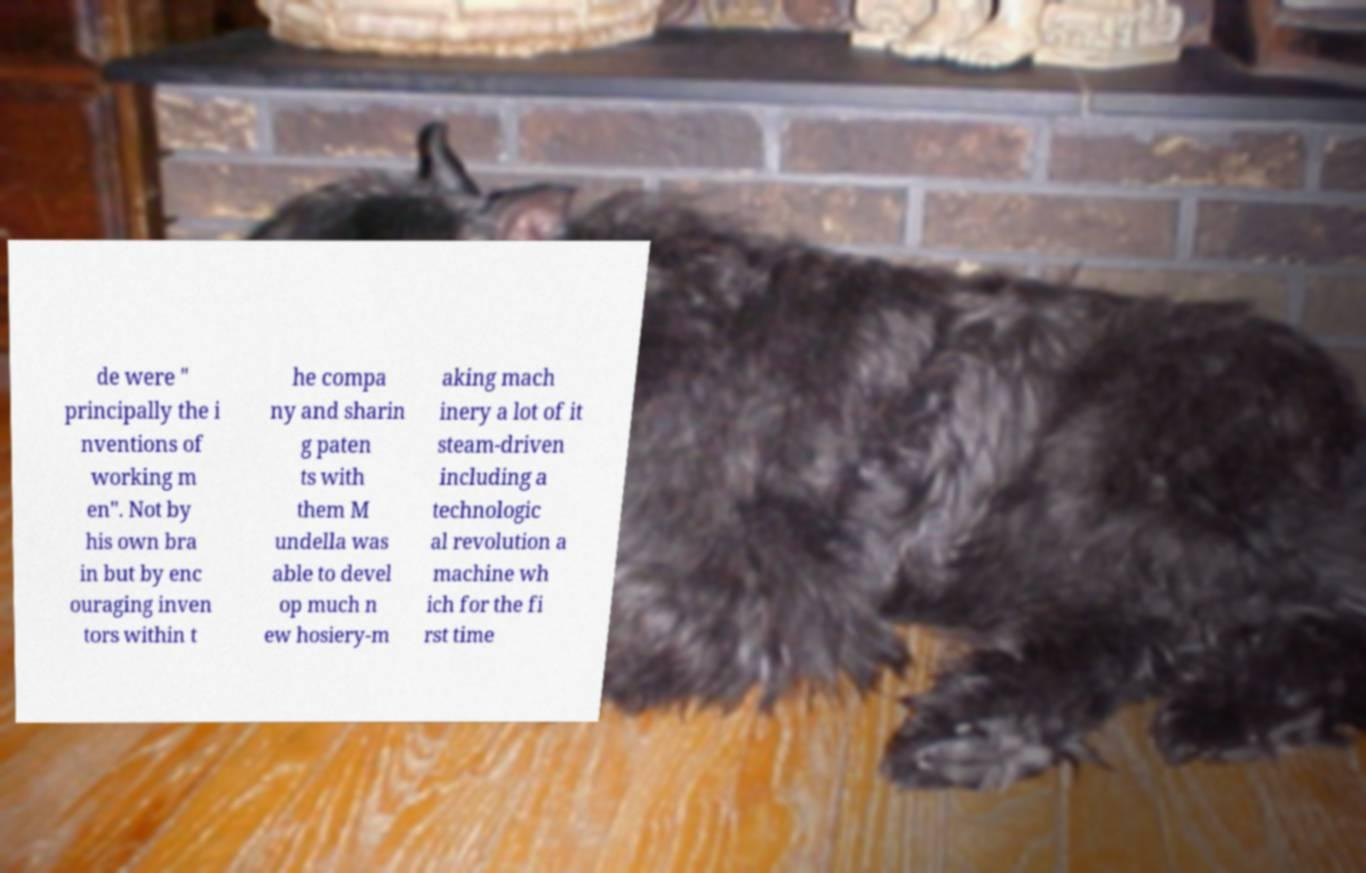I need the written content from this picture converted into text. Can you do that? de were " principally the i nventions of working m en". Not by his own bra in but by enc ouraging inven tors within t he compa ny and sharin g paten ts with them M undella was able to devel op much n ew hosiery-m aking mach inery a lot of it steam-driven including a technologic al revolution a machine wh ich for the fi rst time 